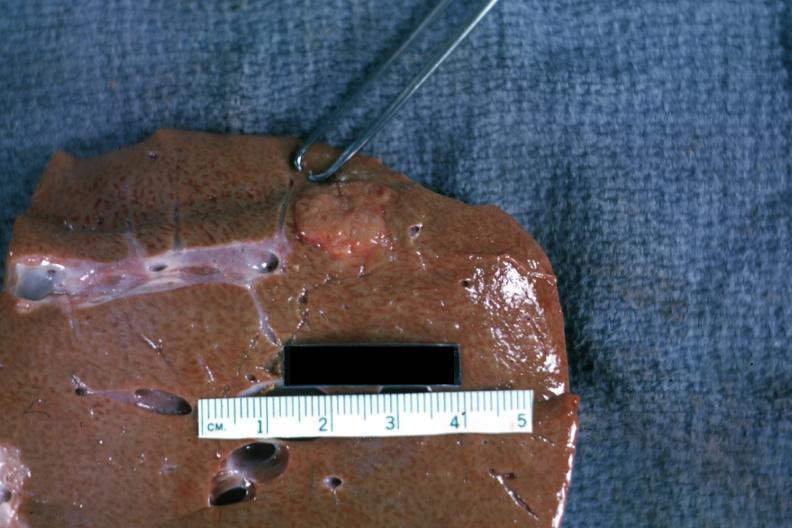s hepatobiliary present?
Answer the question using a single word or phrase. Yes 